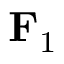<formula> <loc_0><loc_0><loc_500><loc_500>{ F } _ { 1 }</formula> 